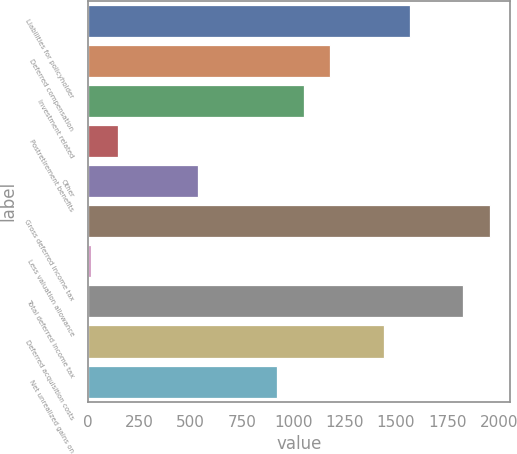<chart> <loc_0><loc_0><loc_500><loc_500><bar_chart><fcel>Liabilities for policyholder<fcel>Deferred compensation<fcel>Investment related<fcel>Postretirement benefits<fcel>Other<fcel>Gross deferred income tax<fcel>Less valuation allowance<fcel>Total deferred income tax<fcel>Deferred acquisition costs<fcel>Net unrealized gains on<nl><fcel>1568.6<fcel>1180.7<fcel>1051.4<fcel>146.3<fcel>534.2<fcel>1956.5<fcel>17<fcel>1827.2<fcel>1439.3<fcel>922.1<nl></chart> 